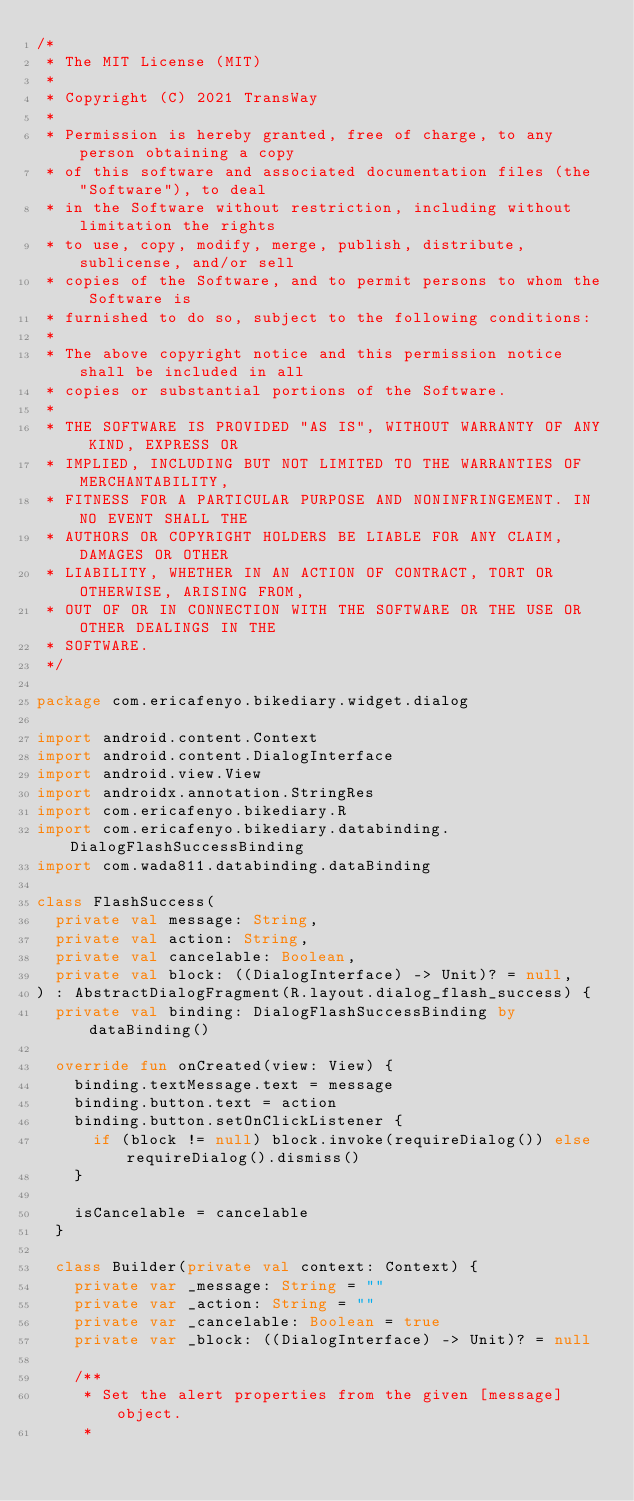Convert code to text. <code><loc_0><loc_0><loc_500><loc_500><_Kotlin_>/*
 * The MIT License (MIT)
 *
 * Copyright (C) 2021 TransWay
 *
 * Permission is hereby granted, free of charge, to any person obtaining a copy
 * of this software and associated documentation files (the "Software"), to deal
 * in the Software without restriction, including without limitation the rights
 * to use, copy, modify, merge, publish, distribute, sublicense, and/or sell
 * copies of the Software, and to permit persons to whom the Software is
 * furnished to do so, subject to the following conditions:
 *
 * The above copyright notice and this permission notice shall be included in all
 * copies or substantial portions of the Software.
 *
 * THE SOFTWARE IS PROVIDED "AS IS", WITHOUT WARRANTY OF ANY KIND, EXPRESS OR
 * IMPLIED, INCLUDING BUT NOT LIMITED TO THE WARRANTIES OF MERCHANTABILITY,
 * FITNESS FOR A PARTICULAR PURPOSE AND NONINFRINGEMENT. IN NO EVENT SHALL THE
 * AUTHORS OR COPYRIGHT HOLDERS BE LIABLE FOR ANY CLAIM, DAMAGES OR OTHER
 * LIABILITY, WHETHER IN AN ACTION OF CONTRACT, TORT OR OTHERWISE, ARISING FROM,
 * OUT OF OR IN CONNECTION WITH THE SOFTWARE OR THE USE OR OTHER DEALINGS IN THE
 * SOFTWARE.
 */

package com.ericafenyo.bikediary.widget.dialog

import android.content.Context
import android.content.DialogInterface
import android.view.View
import androidx.annotation.StringRes
import com.ericafenyo.bikediary.R
import com.ericafenyo.bikediary.databinding.DialogFlashSuccessBinding
import com.wada811.databinding.dataBinding

class FlashSuccess(
  private val message: String,
  private val action: String,
  private val cancelable: Boolean,
  private val block: ((DialogInterface) -> Unit)? = null,
) : AbstractDialogFragment(R.layout.dialog_flash_success) {
  private val binding: DialogFlashSuccessBinding by dataBinding()

  override fun onCreated(view: View) {
    binding.textMessage.text = message
    binding.button.text = action
    binding.button.setOnClickListener {
      if (block != null) block.invoke(requireDialog()) else requireDialog().dismiss()
    }

    isCancelable = cancelable
  }

  class Builder(private val context: Context) {
    private var _message: String = ""
    private var _action: String = ""
    private var _cancelable: Boolean = true
    private var _block: ((DialogInterface) -> Unit)? = null

    /**
     * Set the alert properties from the given [message] object.
     *</code> 